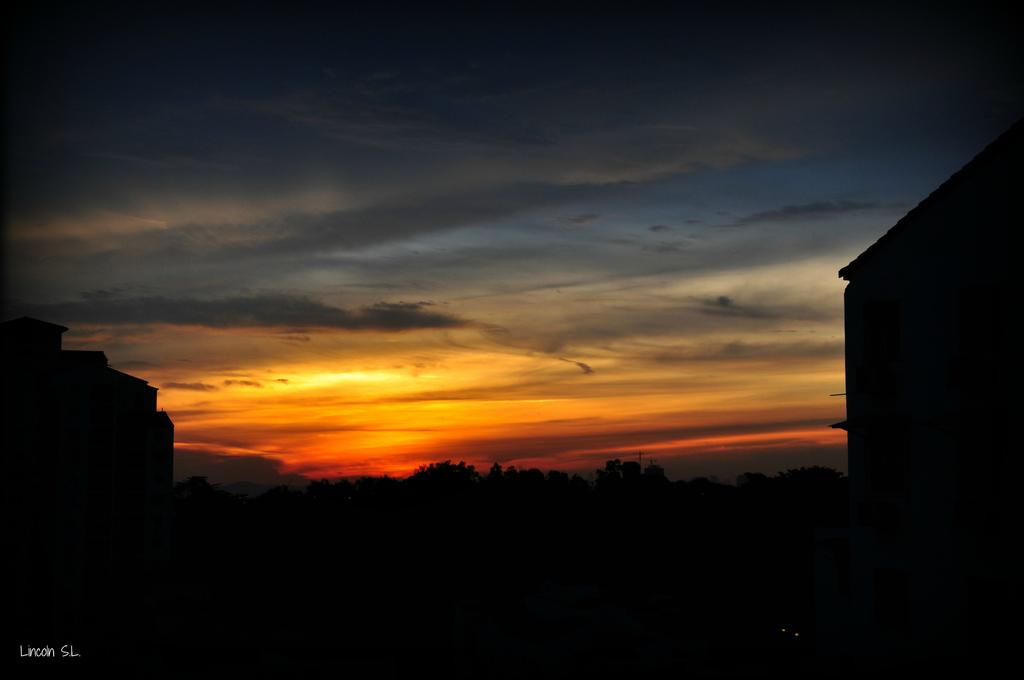What type of structures are in the foreground of the image? There are buildings in the foreground of the image. What can be seen in the middle of the image? There are trees in the middle of the image. What is visible in the background of the image? There is sky visible in the background of the image. How many cakes are being lifted by the buildings in the image? There are no cakes or lifting actions depicted in the image; it features buildings, trees, and sky. What type of regret can be seen on the faces of the trees in the image? There are no faces or emotions depicted on the trees in the image; they are simply trees. 